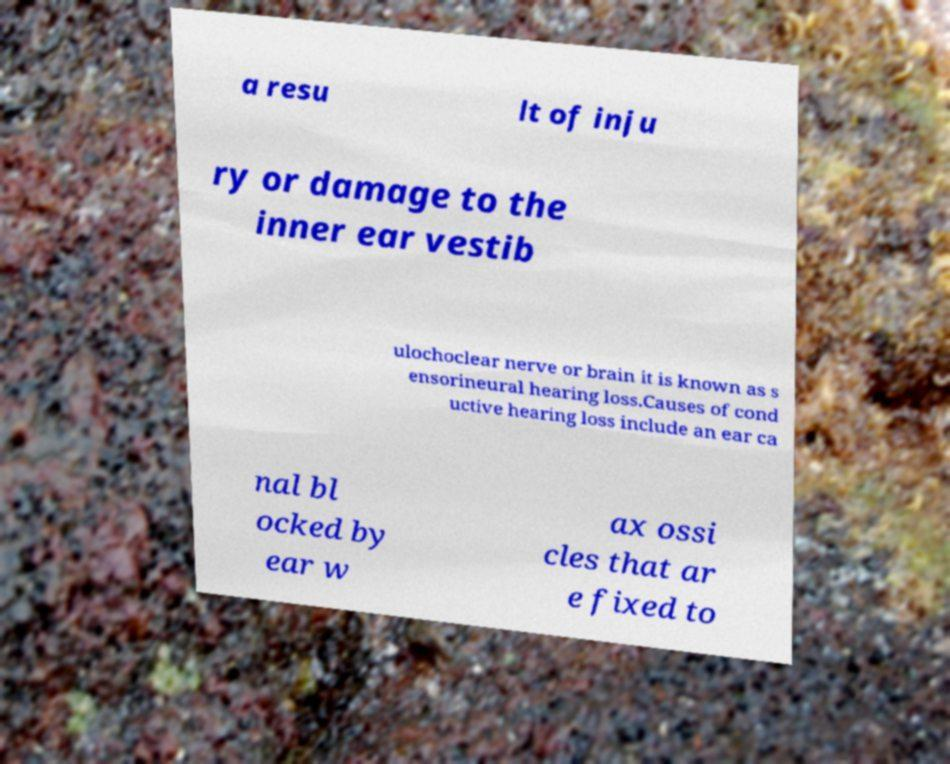Please identify and transcribe the text found in this image. a resu lt of inju ry or damage to the inner ear vestib ulochoclear nerve or brain it is known as s ensorineural hearing loss.Causes of cond uctive hearing loss include an ear ca nal bl ocked by ear w ax ossi cles that ar e fixed to 